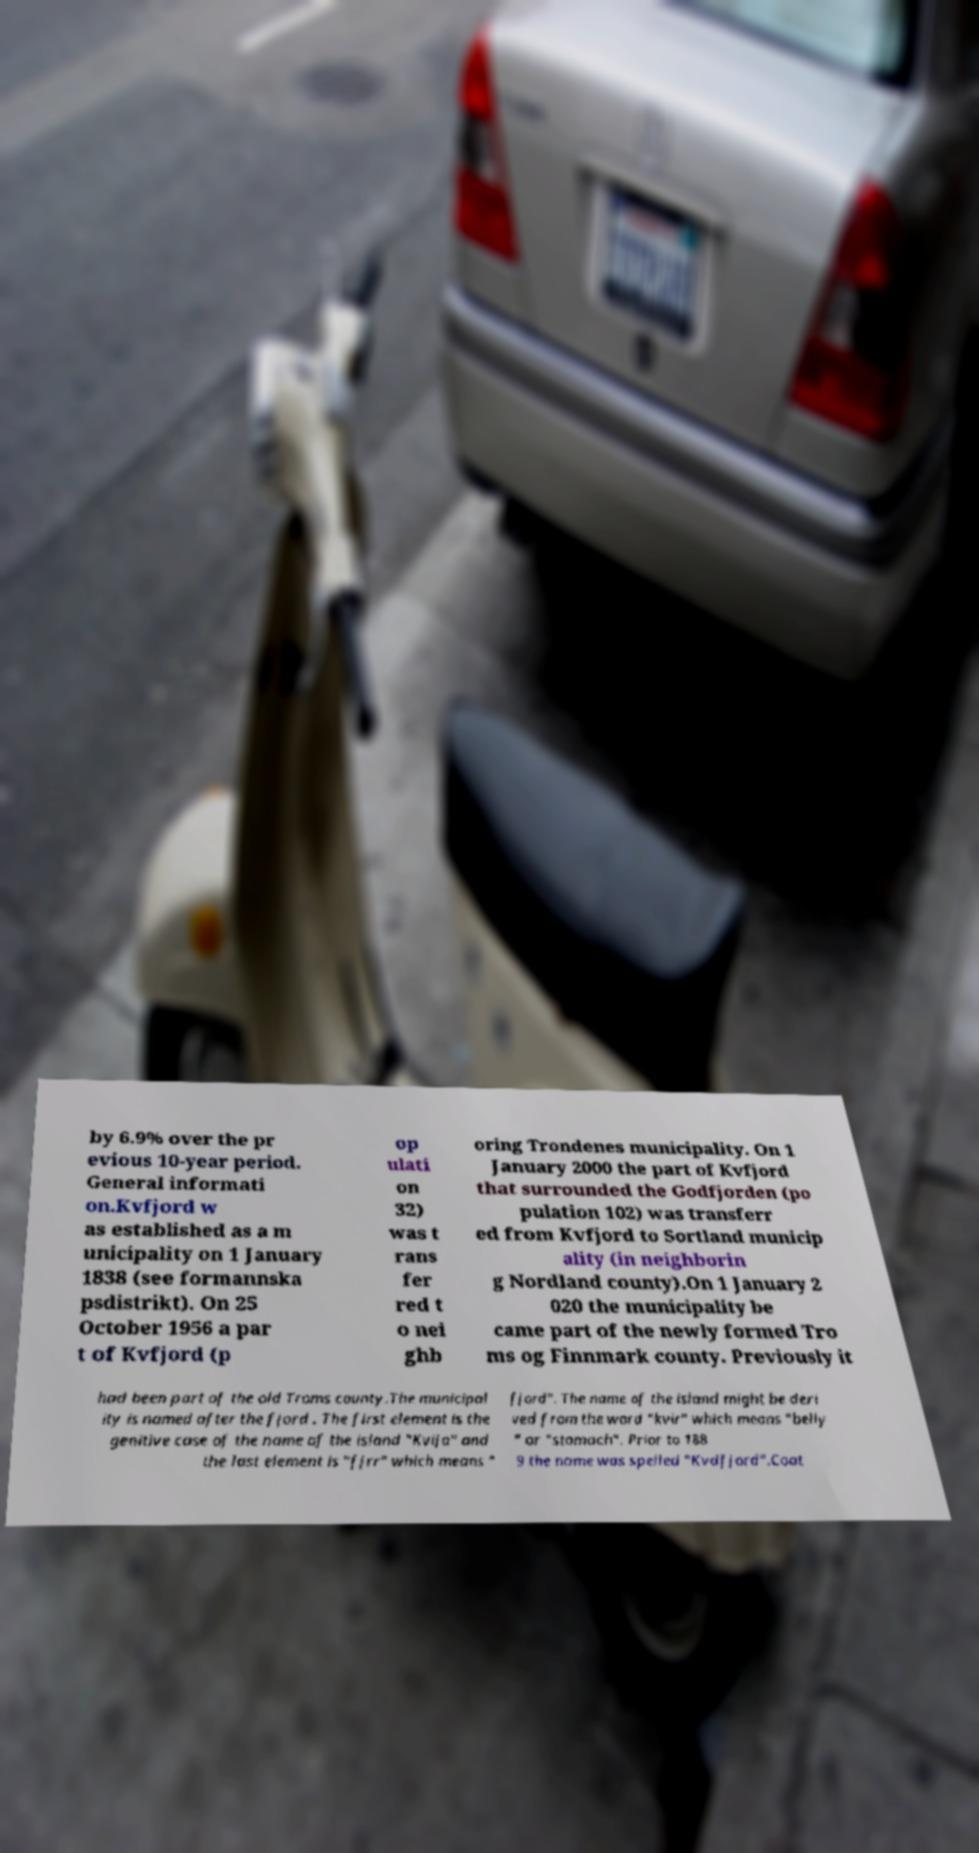What messages or text are displayed in this image? I need them in a readable, typed format. by 6.9% over the pr evious 10-year period. General informati on.Kvfjord w as established as a m unicipality on 1 January 1838 (see formannska psdistrikt). On 25 October 1956 a par t of Kvfjord (p op ulati on 32) was t rans fer red t o nei ghb oring Trondenes municipality. On 1 January 2000 the part of Kvfjord that surrounded the Godfjorden (po pulation 102) was transferr ed from Kvfjord to Sortland municip ality (in neighborin g Nordland county).On 1 January 2 020 the municipality be came part of the newly formed Tro ms og Finnmark county. Previously it had been part of the old Troms county.The municipal ity is named after the fjord . The first element is the genitive case of the name of the island "Kvija" and the last element is "fjrr" which means " fjord". The name of the island might be deri ved from the word "kvir" which means "belly " or "stomach". Prior to 188 9 the name was spelled "Kvdfjord".Coat 